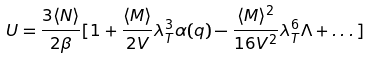<formula> <loc_0><loc_0><loc_500><loc_500>U = \frac { 3 \langle N \rangle } { 2 \beta } [ 1 + \frac { \langle M \rangle } { 2 V } \lambda _ { T } ^ { 3 } \alpha ( q ) - \frac { \langle M \rangle ^ { 2 } } { 1 6 V ^ { 2 } } \lambda _ { T } ^ { 6 } \Lambda + \dots ]</formula> 